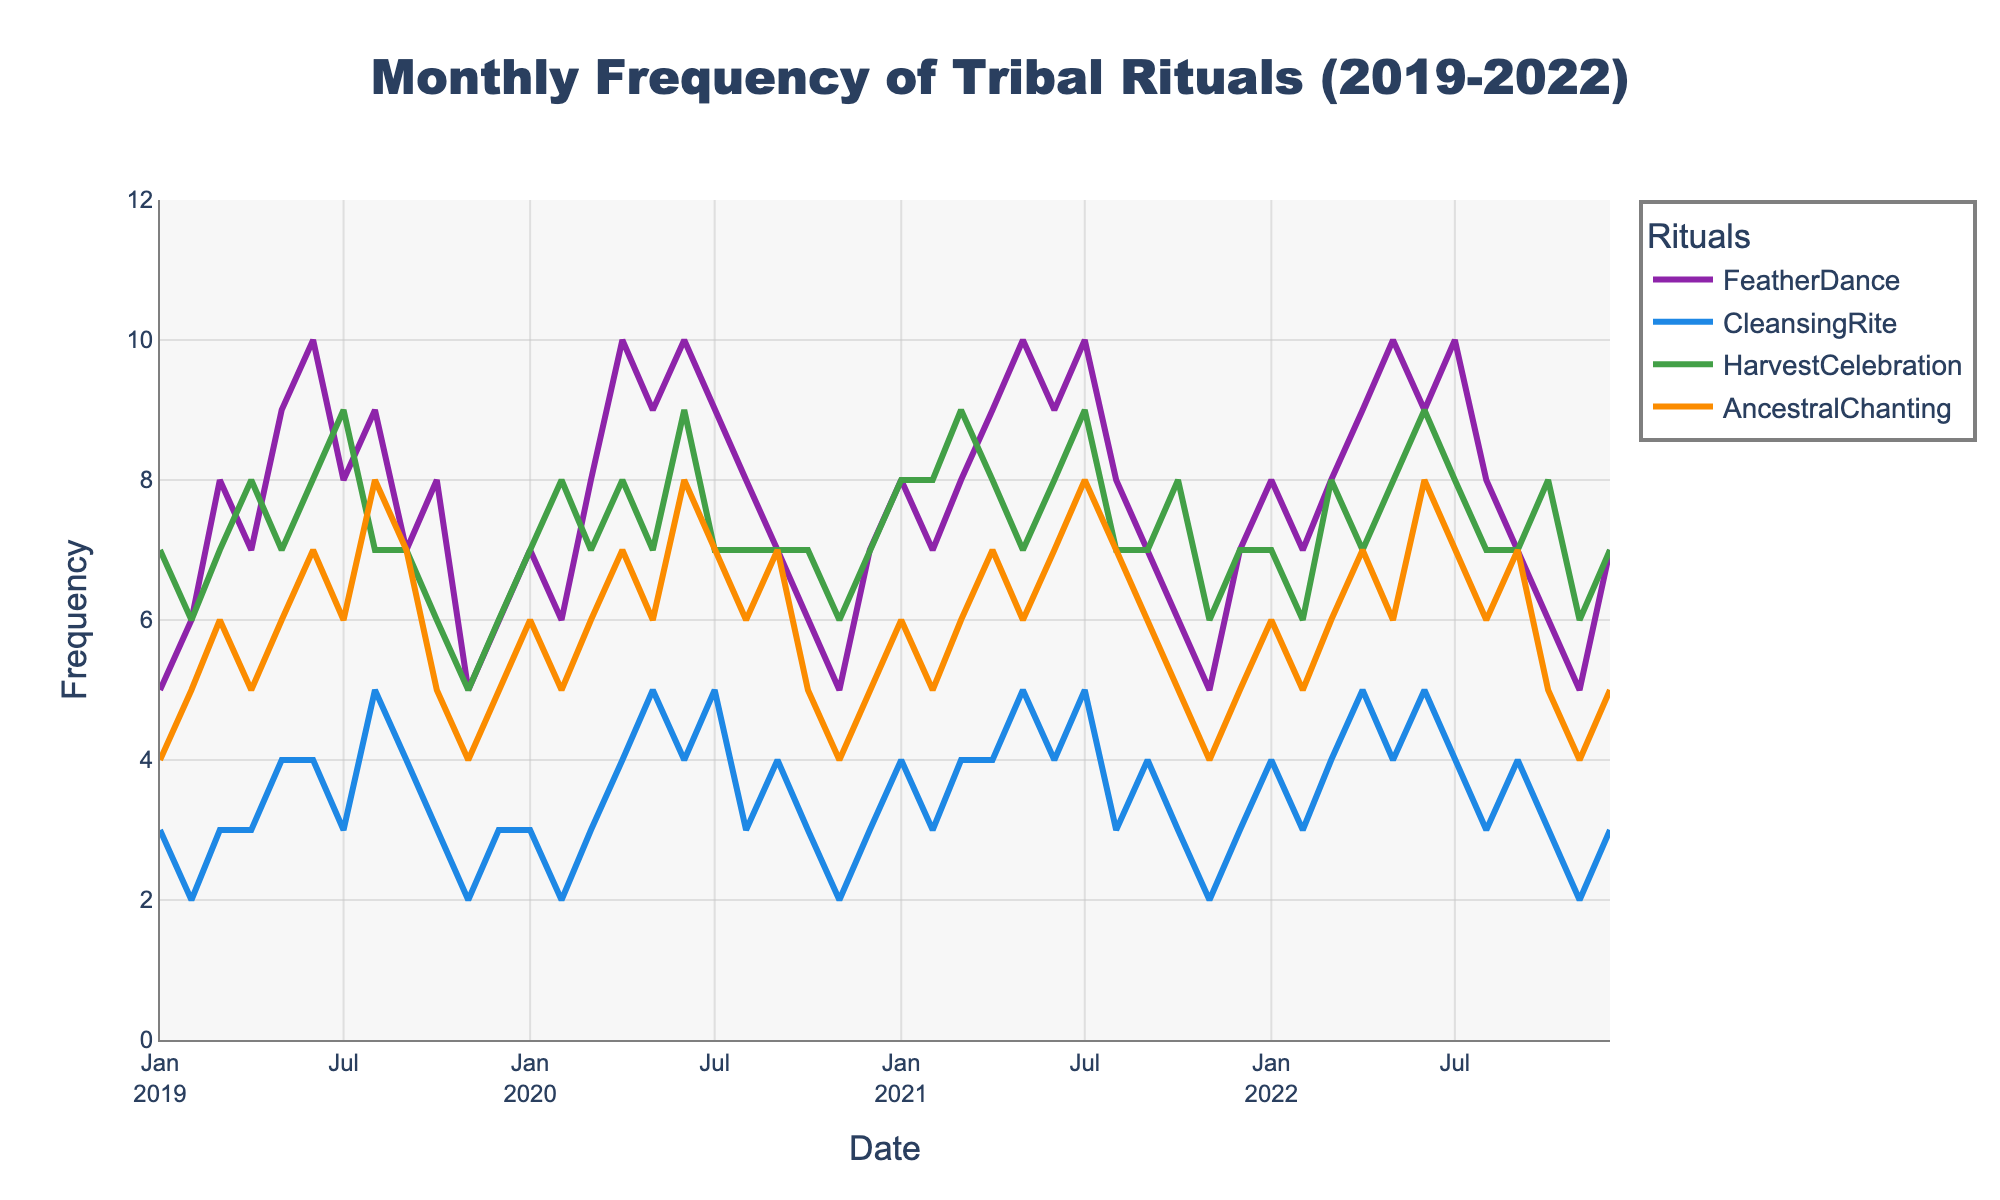What is the title of the chart? The title of the chart is located at the top and provides an overview of what the chart represents. By looking at the top-center of the figure, we can see the title.
Answer: Monthly Frequency of Tribal Rituals (2019-2022) Which ritual has the highest frequency in January 2021? To find this, locate January 2021 on the x-axis and look at the values for each ritual on the y-axis. The highest line at this point indicates the ritual with the highest frequency.
Answer: FeatherDance What is the average frequency of CleansingRite in the year 2020? First, sum up the CleansingRite frequencies for each month in 2020: 3 + 2 + 3 + 4 + 5 + 4 + 5 + 3 + 4 + 3 + 2 + 3 = 37. Then, divide by 12 (number of months) to get the average. 37/12 = 3.08
Answer: 3.08 Which ritual had the most significant increase in frequency from January 2019 to June 2019? Compare the frequencies of each ritual in January and June 2019. Calculate the difference for each ritual and identify the largest one. FeatherDance: 10 - 5 = 5, CleansingRite: 4 - 3 = 1, HarvestCelebration: 8 - 7 = 1, AncestralChanting: 7 - 4 = 3. The ritual with the highest difference is FeatherDance.
Answer: FeatherDance Between July and December 2021, which ritual shows the least variation in frequency? Look at each ritual's frequencies from July to December 2021. Calculate the range (max - min) for each. FeatherDance: 10 - 7 = 3, CleansingRite: 5 - 3 = 2, HarvestCelebration: 9 - 7 = 2, AncestralChanting: 8 - 5 = 3. The ritual with the smallest range is CleansingRite and HarvestCelebration with 2.
Answer: CleansingRite and HarvestCelebration How many times does the frequency of HarvestCelebration reach its maximum value in the dataset? The maximum frequency value for HarvestCelebration is 9. Count the instances where HarvestCelebration reaches the value of 9. These are in March 2021, June 2020, and July 2021.
Answer: 3 What is the frequency difference of AncestralChanting between November 2019 and November 2022? Find the AncestralChanting frequency for November 2019 and November 2022. Subtract the former from the latter. November 2019: 4, November 2022: 4. Difference: 4 - 4 = 0
Answer: 0 Which ritual showed a consistent frequency pattern across the years? Identify the ritual whose frequency shows minimal fluctuation over time. CleansingRite's frequency oscillates around 3-4, suggesting a relatively stable pattern.
Answer: CleansingRite In which year did FeatherDance have the highest overall frequency? Sum FeatherDance frequencies for each year and compare. 2019: 5+6+8+7+9+10+8+9+7+8+5+6=88, 2020: 7+6+8+10+9+10+9+8+7+6+5+7=92, 2021: 8+7+8+9+10+9+10+8+7+6+5+7=94, 2022: 8+7+8+9+10+9+10+8+7+6+5+7=94.
Answer: 2021 and 2022 What is the trend of HarvestCelebration over the observed years? Observe the HarvestCelebration line from 2019 to 2022. Generally, it fluctuates with peaks in Aprils, showing some increase but not consistently.
Answer: Fluctuating 